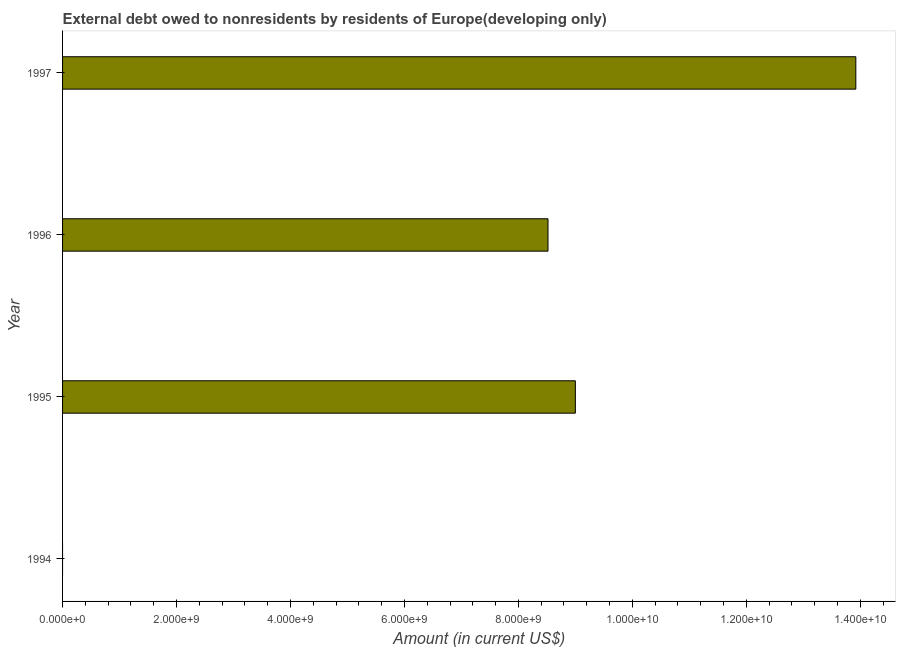Does the graph contain any zero values?
Your answer should be compact. Yes. What is the title of the graph?
Offer a terse response. External debt owed to nonresidents by residents of Europe(developing only). What is the label or title of the Y-axis?
Give a very brief answer. Year. What is the debt in 1995?
Keep it short and to the point. 9.00e+09. Across all years, what is the maximum debt?
Your response must be concise. 1.39e+1. In which year was the debt maximum?
Provide a succinct answer. 1997. What is the sum of the debt?
Keep it short and to the point. 3.14e+1. What is the difference between the debt in 1995 and 1996?
Offer a terse response. 4.80e+08. What is the average debt per year?
Make the answer very short. 7.86e+09. What is the median debt?
Ensure brevity in your answer.  8.76e+09. In how many years, is the debt greater than 1200000000 US$?
Offer a very short reply. 3. What is the ratio of the debt in 1995 to that in 1996?
Make the answer very short. 1.06. What is the difference between the highest and the second highest debt?
Ensure brevity in your answer.  4.92e+09. What is the difference between the highest and the lowest debt?
Offer a terse response. 1.39e+1. How many bars are there?
Offer a very short reply. 3. Are all the bars in the graph horizontal?
Offer a very short reply. Yes. How many years are there in the graph?
Keep it short and to the point. 4. Are the values on the major ticks of X-axis written in scientific E-notation?
Provide a short and direct response. Yes. What is the Amount (in current US$) of 1995?
Provide a succinct answer. 9.00e+09. What is the Amount (in current US$) of 1996?
Make the answer very short. 8.52e+09. What is the Amount (in current US$) in 1997?
Provide a short and direct response. 1.39e+1. What is the difference between the Amount (in current US$) in 1995 and 1996?
Keep it short and to the point. 4.80e+08. What is the difference between the Amount (in current US$) in 1995 and 1997?
Offer a terse response. -4.92e+09. What is the difference between the Amount (in current US$) in 1996 and 1997?
Make the answer very short. -5.40e+09. What is the ratio of the Amount (in current US$) in 1995 to that in 1996?
Your answer should be very brief. 1.06. What is the ratio of the Amount (in current US$) in 1995 to that in 1997?
Keep it short and to the point. 0.65. What is the ratio of the Amount (in current US$) in 1996 to that in 1997?
Your answer should be compact. 0.61. 